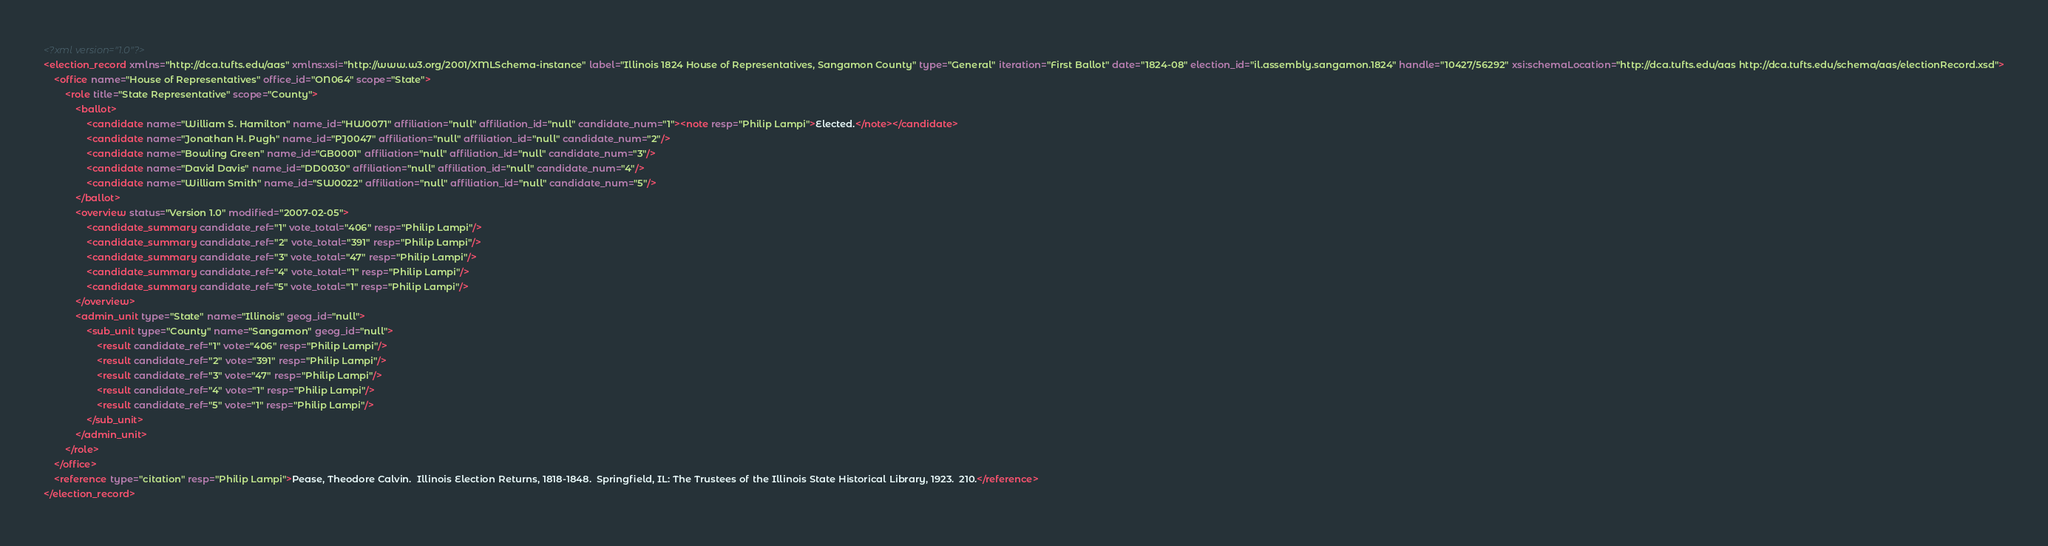<code> <loc_0><loc_0><loc_500><loc_500><_XML_><?xml version="1.0"?>
<election_record xmlns="http://dca.tufts.edu/aas" xmlns:xsi="http://www.w3.org/2001/XMLSchema-instance" label="Illinois 1824 House of Representatives, Sangamon County" type="General" iteration="First Ballot" date="1824-08" election_id="il.assembly.sangamon.1824" handle="10427/56292" xsi:schemaLocation="http://dca.tufts.edu/aas http://dca.tufts.edu/schema/aas/electionRecord.xsd">
	<office name="House of Representatives" office_id="ON064" scope="State">
		<role title="State Representative" scope="County">
			<ballot>
				<candidate name="William S. Hamilton" name_id="HW0071" affiliation="null" affiliation_id="null" candidate_num="1"><note resp="Philip Lampi">Elected.</note></candidate>
				<candidate name="Jonathan H. Pugh" name_id="PJ0047" affiliation="null" affiliation_id="null" candidate_num="2"/>
				<candidate name="Bowling Green" name_id="GB0001" affiliation="null" affiliation_id="null" candidate_num="3"/>
				<candidate name="David Davis" name_id="DD0030" affiliation="null" affiliation_id="null" candidate_num="4"/>
				<candidate name="William Smith" name_id="SW0022" affiliation="null" affiliation_id="null" candidate_num="5"/>
			</ballot>
			<overview status="Version 1.0" modified="2007-02-05">
				<candidate_summary candidate_ref="1" vote_total="406" resp="Philip Lampi"/>
				<candidate_summary candidate_ref="2" vote_total="391" resp="Philip Lampi"/>
				<candidate_summary candidate_ref="3" vote_total="47" resp="Philip Lampi"/>
				<candidate_summary candidate_ref="4" vote_total="1" resp="Philip Lampi"/>
				<candidate_summary candidate_ref="5" vote_total="1" resp="Philip Lampi"/>
			</overview>
			<admin_unit type="State" name="Illinois" geog_id="null">
				<sub_unit type="County" name="Sangamon" geog_id="null">
					<result candidate_ref="1" vote="406" resp="Philip Lampi"/>
					<result candidate_ref="2" vote="391" resp="Philip Lampi"/>
					<result candidate_ref="3" vote="47" resp="Philip Lampi"/>
					<result candidate_ref="4" vote="1" resp="Philip Lampi"/>
					<result candidate_ref="5" vote="1" resp="Philip Lampi"/>
				</sub_unit>
			</admin_unit>
		</role>
	</office>
	<reference type="citation" resp="Philip Lampi">Pease, Theodore Calvin.  Illinois Election Returns, 1818-1848.  Springfield, IL: The Trustees of the Illinois State Historical Library, 1923.  210.</reference>
</election_record>
</code> 